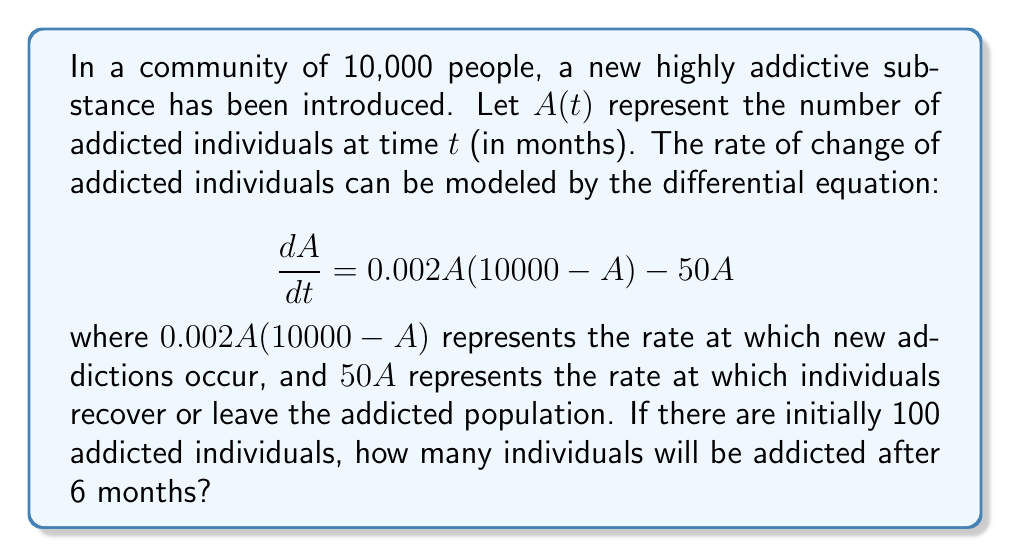Teach me how to tackle this problem. To solve this problem, we need to use the given differential equation and initial condition to find $A(t)$ at $t = 6$. Here's a step-by-step approach:

1) First, let's rearrange the differential equation:

   $$\frac{dA}{dt} = 0.002A(10000 - A) - 50A = 20A - 0.002A^2 - 50A = -0.002A^2 - 30A$$

2) This is a separable differential equation. We can rewrite it as:

   $$\frac{dA}{-0.002A^2 - 30A} = dt$$

3) Integrate both sides:

   $$\int \frac{dA}{-0.002A^2 - 30A} = \int dt$$

4) The left side can be integrated using partial fractions:

   $$-\frac{1}{30} \ln|A| + \frac{1}{30} \ln|A + 15000| = t + C$$

5) Apply the initial condition: $A(0) = 100$

   $$-\frac{1}{30} \ln|100| + \frac{1}{30} \ln|15100| = C$$

6) Substitute this back into the general solution:

   $$-\frac{1}{30} \ln|A| + \frac{1}{30} \ln|A + 15000| = t - \frac{1}{30} \ln|100| + \frac{1}{30} \ln|15100|$$

7) Simplify and solve for $A$:

   $$\frac{A + 15000}{A} = \frac{15100}{100} e^{30t}$$

   $$A + 15000 = 151A e^{30t}$$

   $$A = \frac{15000}{151e^{30t} - 1}$$

8) Now, we can find $A(6)$ by plugging in $t = 6$:

   $$A(6) = \frac{15000}{151e^{180} - 1} \approx 99.34$$

9) Since we're dealing with individuals, we round to the nearest whole number.
Answer: After 6 months, approximately 99 individuals will be addicted. 